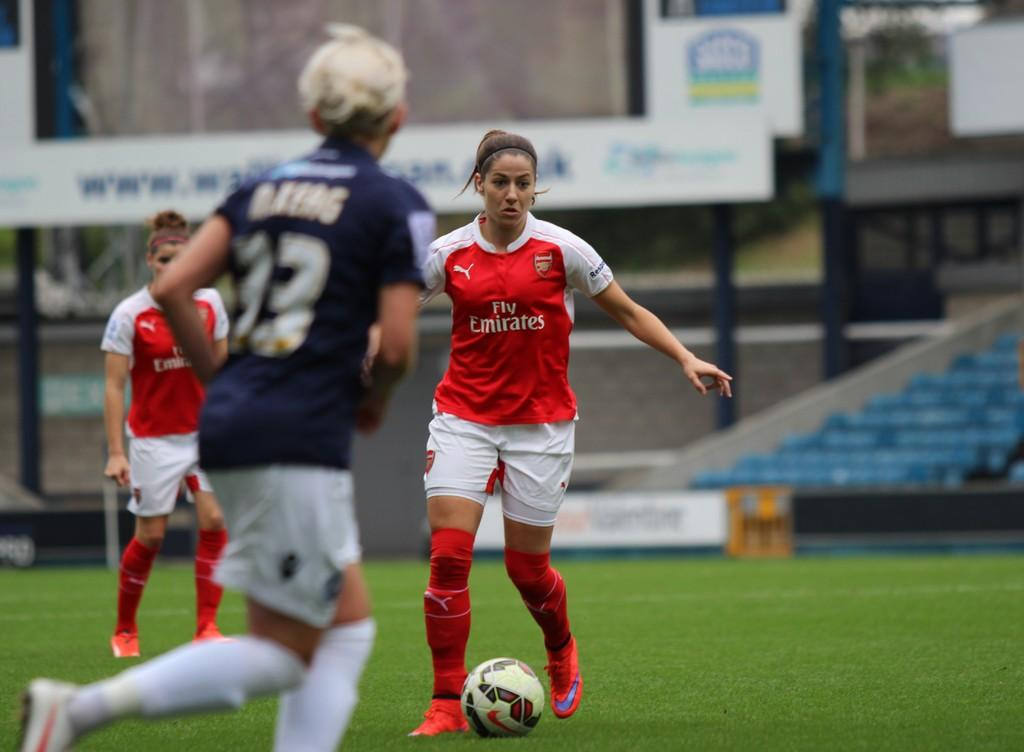Where was the image taken? The image was taken in a stadium. How many players are visible in the image? There are three players in the image. What are the players doing in the image? The players are playing with a ball. What else can be seen in the image besides the players? The playground is visible in the image. What type of grip does the player on the left have on the rings in the image? There are no rings present in the image, and the players are playing with a ball, not gripping any rings. 